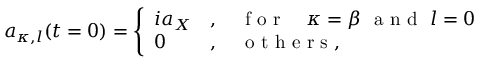Convert formula to latex. <formula><loc_0><loc_0><loc_500><loc_500>a _ { \kappa , l } ( t = 0 ) = \left \{ { \begin{array} { l l } { i a _ { X } } & { , \quad f o r \quad \kappa = \beta \ a n d \ l = 0 } \\ { 0 } & { , \quad o t h e r s , } \end{array} }</formula> 